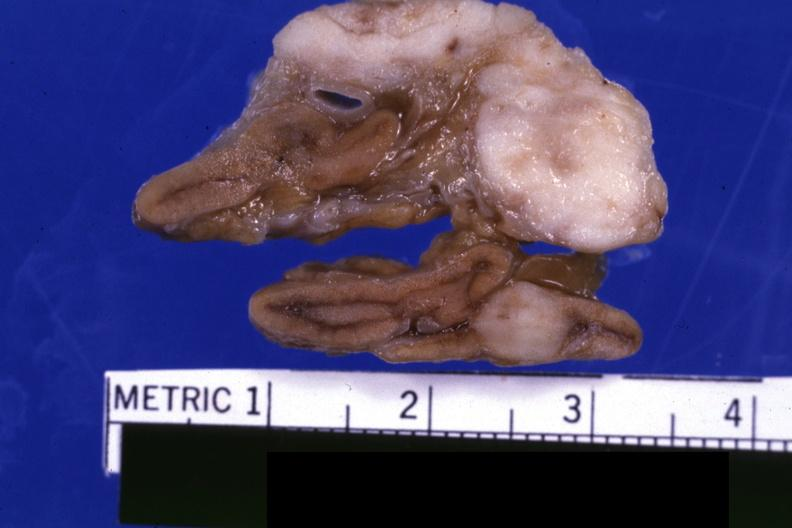s adrenal present?
Answer the question using a single word or phrase. Yes 